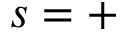<formula> <loc_0><loc_0><loc_500><loc_500>s = +</formula> 